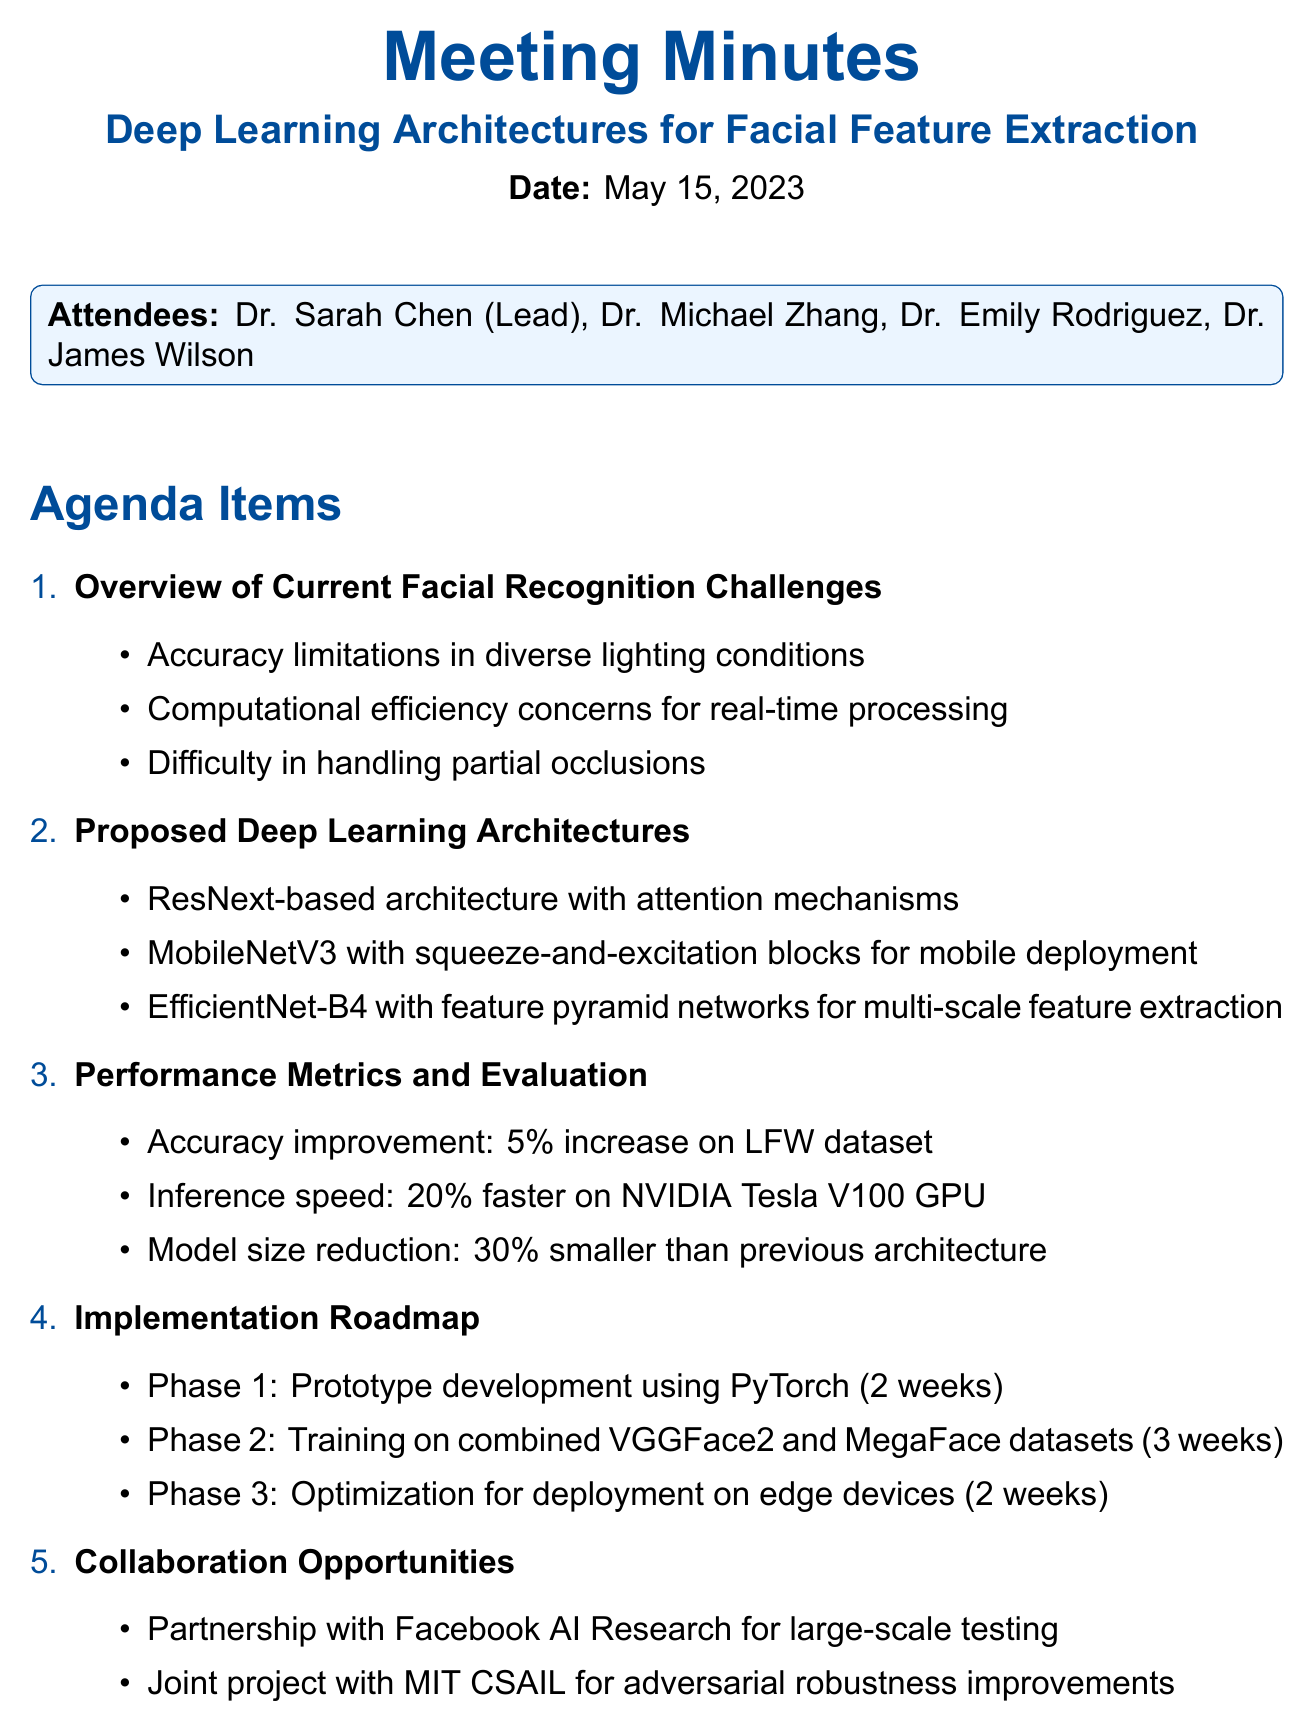What is the title of the meeting? The title of the meeting is stated in the document under "meeting_title."
Answer: Deep Learning Architectures for Facial Feature Extraction Who is the lead computer scientist? The lead computer scientist is mentioned in the list of attendees.
Answer: Dr. Sarah Chen What are the proposed architectures? The proposed architectures are listed under the agenda item titled "Proposed Deep Learning Architectures."
Answer: ResNext-based architecture, MobileNetV3, EfficientNet-B4 What is the accuracy improvement percentage on the LFW dataset? The accuracy improvement is detailed under "Performance Metrics and Evaluation," specifying the increase percentage on the LFW dataset.
Answer: 5% What is the length of Phase 1 for prototype development? The length of Phase 1 is outlined in the "Implementation Roadmap."
Answer: 2 weeks What is the date of the next meeting? The date of the next meeting is provided in the document under "Next Meeting."
Answer: May 29, 2023 What is an action item for Dr. Rodriguez? The action items are listed in the "Action Items" section, mentioning Dr. Rodriguez's tasks.
Answer: Prepare dataset for training and validation What collaboration opportunity is mentioned? The collaboration opportunities are mentioned in the corresponding agenda item.
Answer: Partnership with Facebook AI Research 